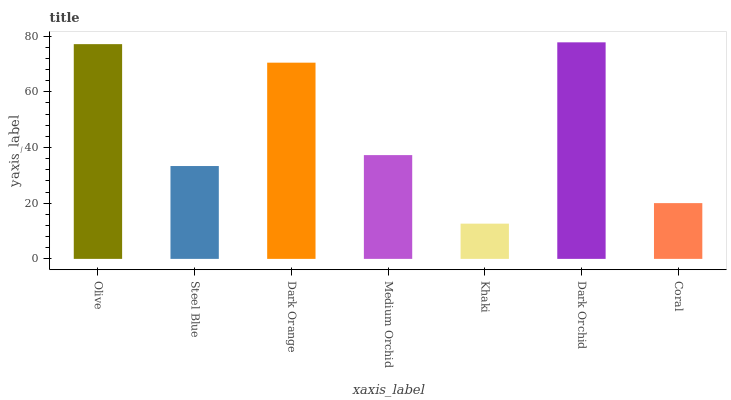Is Khaki the minimum?
Answer yes or no. Yes. Is Dark Orchid the maximum?
Answer yes or no. Yes. Is Steel Blue the minimum?
Answer yes or no. No. Is Steel Blue the maximum?
Answer yes or no. No. Is Olive greater than Steel Blue?
Answer yes or no. Yes. Is Steel Blue less than Olive?
Answer yes or no. Yes. Is Steel Blue greater than Olive?
Answer yes or no. No. Is Olive less than Steel Blue?
Answer yes or no. No. Is Medium Orchid the high median?
Answer yes or no. Yes. Is Medium Orchid the low median?
Answer yes or no. Yes. Is Dark Orange the high median?
Answer yes or no. No. Is Coral the low median?
Answer yes or no. No. 